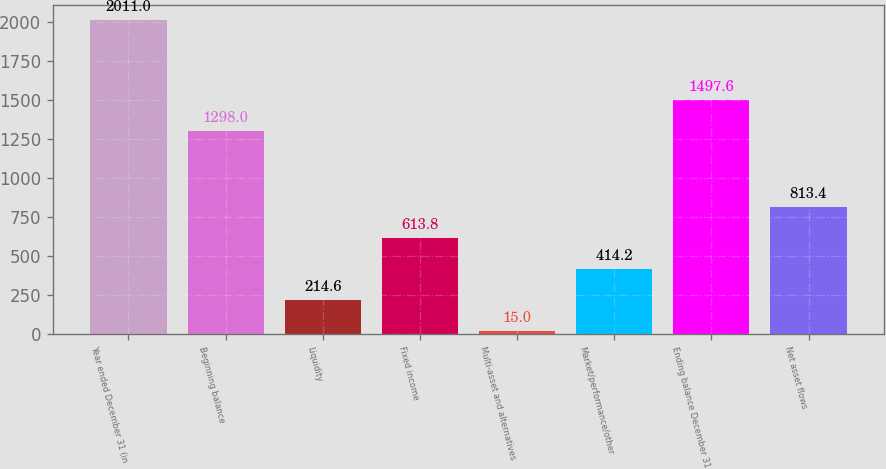Convert chart to OTSL. <chart><loc_0><loc_0><loc_500><loc_500><bar_chart><fcel>Year ended December 31 (in<fcel>Beginning balance<fcel>Liquidity<fcel>Fixed income<fcel>Multi-asset and alternatives<fcel>Market/performance/other<fcel>Ending balance December 31<fcel>Net asset flows<nl><fcel>2011<fcel>1298<fcel>214.6<fcel>613.8<fcel>15<fcel>414.2<fcel>1497.6<fcel>813.4<nl></chart> 